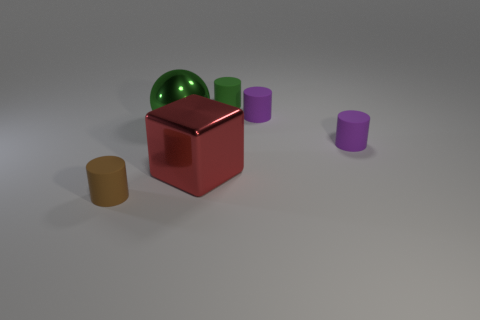Add 2 rubber things. How many objects exist? 8 Subtract all cylinders. How many objects are left? 2 Add 5 brown rubber cylinders. How many brown rubber cylinders are left? 6 Add 5 big red spheres. How many big red spheres exist? 5 Subtract 0 gray cylinders. How many objects are left? 6 Subtract all small brown cylinders. Subtract all large red objects. How many objects are left? 4 